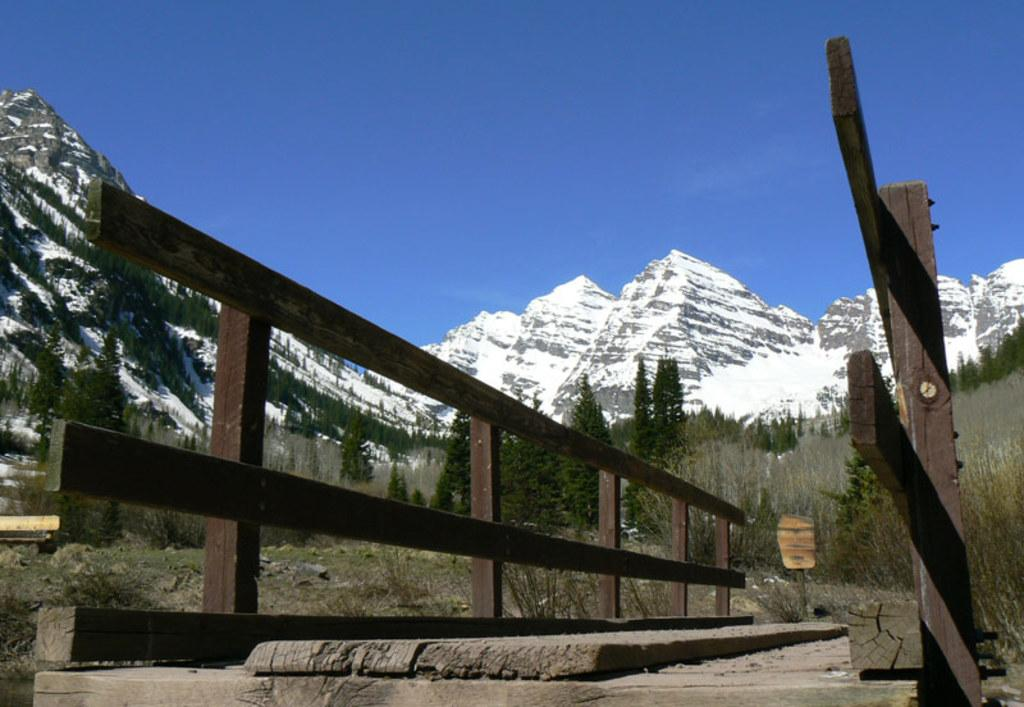What type of structure is present in the image? There is a wooden bridge in the image. What type of vegetation can be seen in the image? There are trees, plants, and grass visible in the image. What is the color of the sky in the image? The sky is blue in the image. What type of landscape feature is visible in the image? There are hills visible in the image. What type of song is being sung by the geese in the image? There are no geese present in the image, so there is no song being sung. What topic is being discussed by the plants in the image? Plants do not have the ability to discuss topics, so there is no discussion happening among them in the image. 